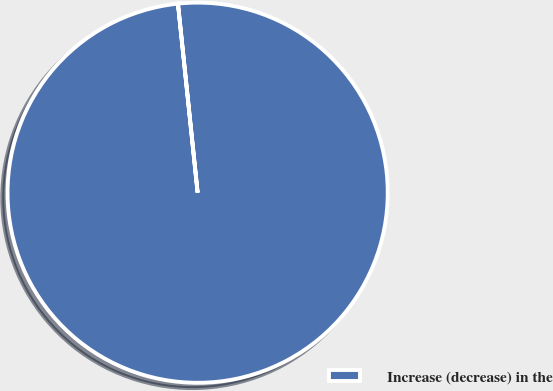Convert chart to OTSL. <chart><loc_0><loc_0><loc_500><loc_500><pie_chart><fcel>Increase (decrease) in the<nl><fcel>100.0%<nl></chart> 